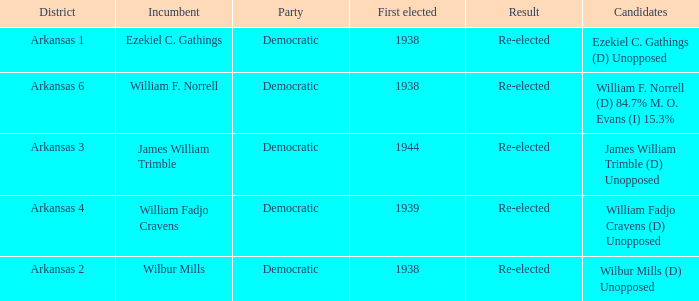Which party has a first elected number bigger than 1939.0? Democratic. 